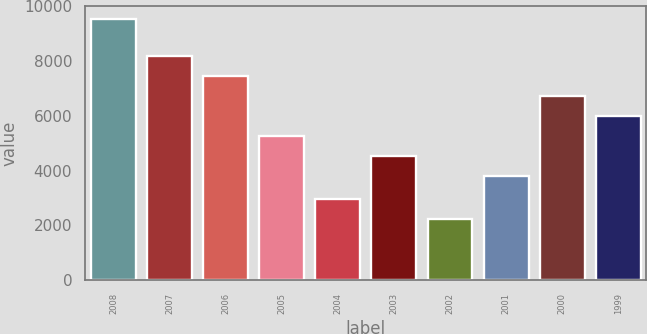Convert chart to OTSL. <chart><loc_0><loc_0><loc_500><loc_500><bar_chart><fcel>2008<fcel>2007<fcel>2006<fcel>2005<fcel>2004<fcel>2003<fcel>2002<fcel>2001<fcel>2000<fcel>1999<nl><fcel>9531<fcel>8197.4<fcel>7468<fcel>5279.8<fcel>2966.4<fcel>4550.4<fcel>2237<fcel>3821<fcel>6738.6<fcel>6009.2<nl></chart> 